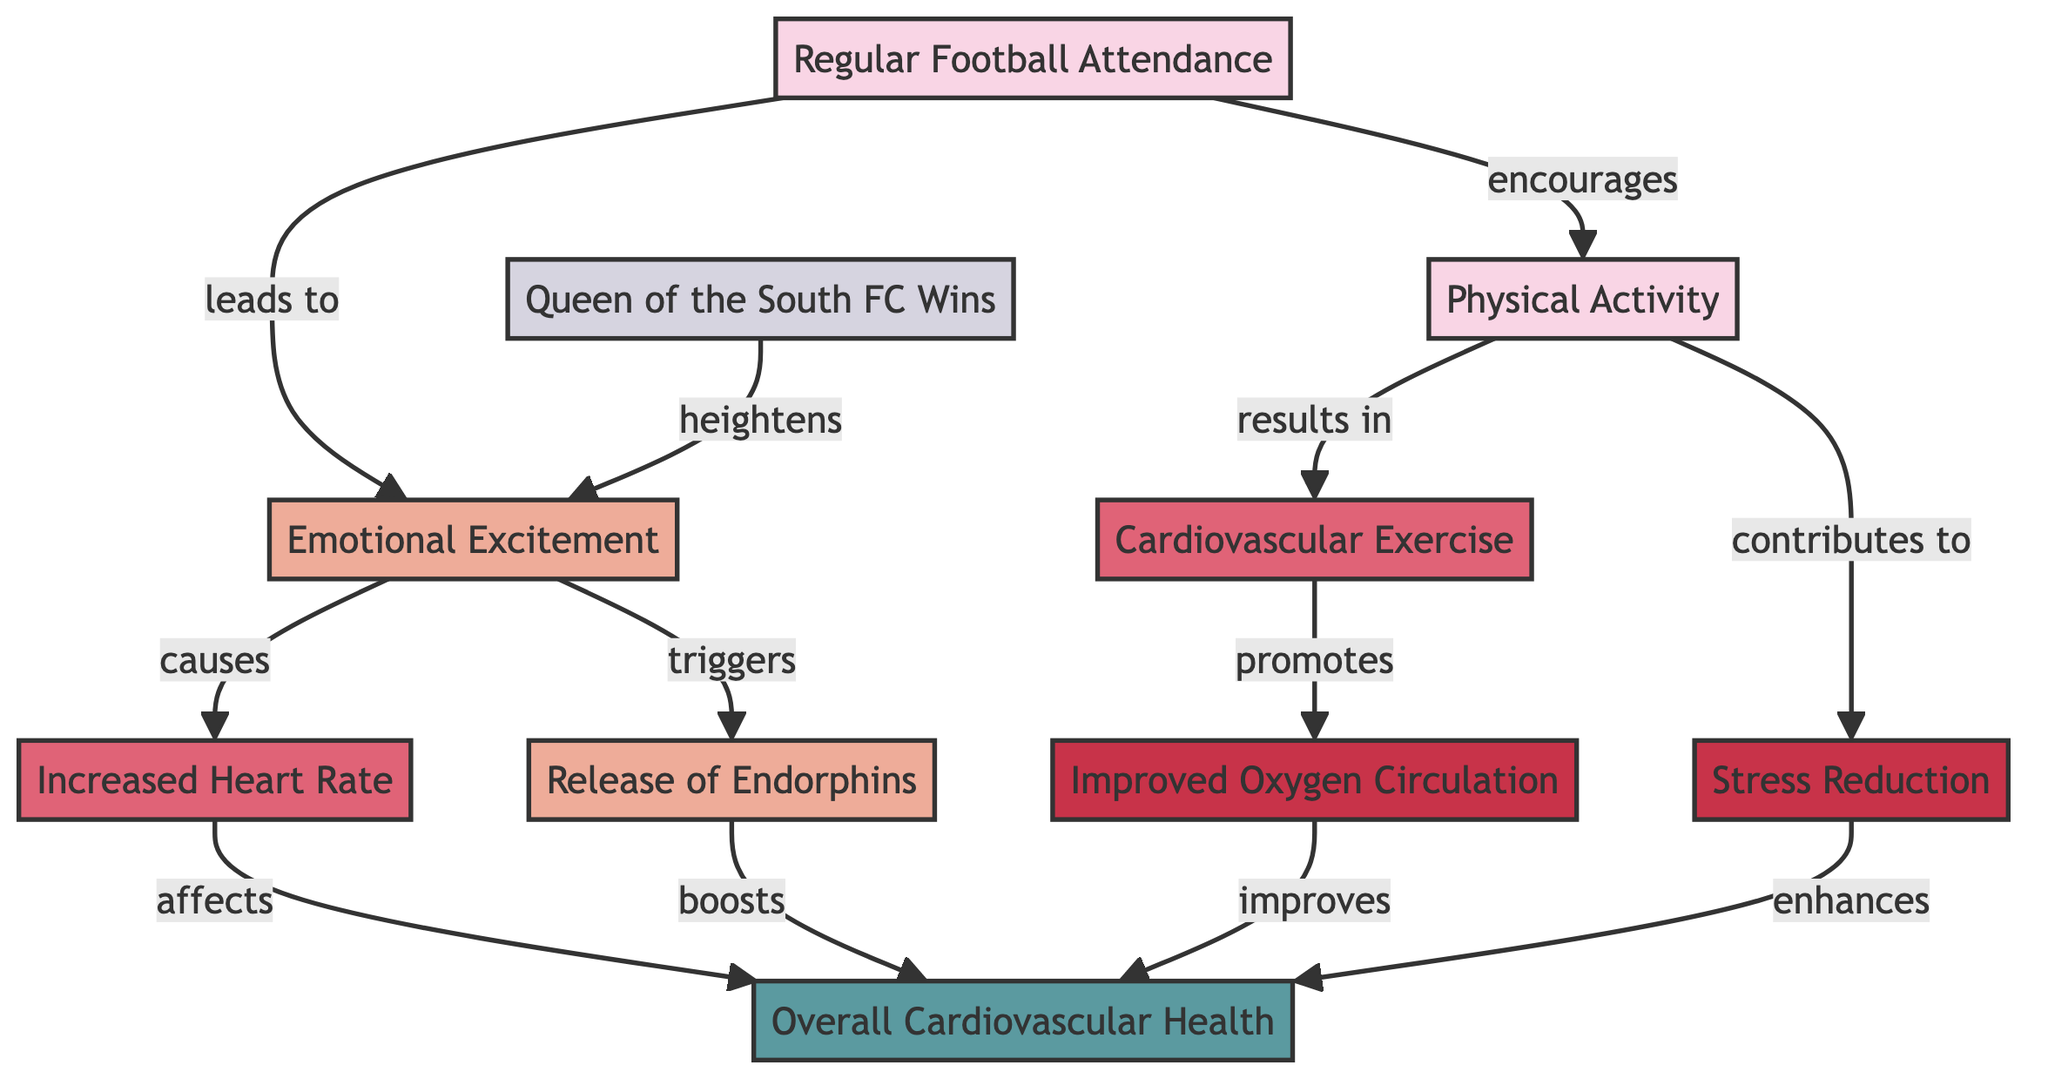What is the first node in the diagram? The first node is labeled "Regular Football Attendance" and it serves as the starting point in the flowchart.
Answer: Regular Football Attendance How many direct effects does "Regular Football Attendance" have? "Regular Football Attendance" directly leads to two responses: "Emotional Excitement" and "Physical Activity," making it two direct effects.
Answer: 2 What does "Emotional Excitement" lead to? The node "Emotional Excitement" directly causes an "Increased Heart Rate," which is another effect shown in the diagram.
Answer: Increased Heart Rate What is the relationship between "Physical Activity" and "Overall Cardiovascular Health"? "Physical Activity" leads to "Cardiovascular Exercise," which then promotes "Improved Oxygen Circulation" and contributes positively to "Overall Cardiovascular Health." Thus, there is a chain effect where one node influences the next toward the overall health result.
Answer: Promotes What triggers the "Release of Endorphins"? The diagram shows that "Emotional Excitement" triggers the "Release of Endorphins," establishing a direct causal relationship between these two nodes.
Answer: Emotional Excitement What benefit is associated with "Stress Reduction"? The node "Stress Reduction" is indicated as a benefit that contributes to "Overall Cardiovascular Health," improving the individual's well-being in relation to their heart health.
Answer: Overall Cardiovascular Health How does a win by "Queen of the South FC" influence emotional excitement? The win enhances emotional excitement, which denotes a direct influence where team success heightens the positive emotional response of fans.
Answer: Heightens Which two benefits improve "Overall Cardiovascular Health"? The benefits that improve "Overall Cardiovascular Health" are "Improved Oxygen Circulation" and "Stress Reduction," both of which contribute positively to heart health.
Answer: Improved Oxygen Circulation and Stress Reduction 